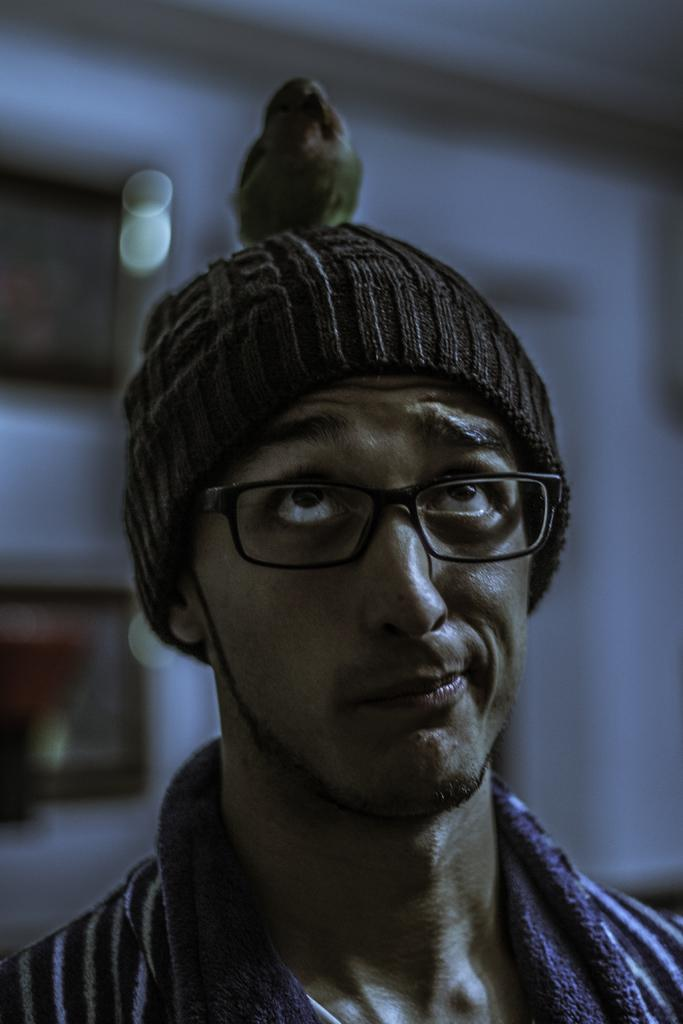What is the main subject of the picture? The main subject of the picture is a man. Can you describe what the man is wearing? The man is wearing a cap. Are there any animals present in the image? Yes, there is a bird on the man's head. What type of curtain can be seen in the background of the image? There is no curtain present in the image; it features a man with a bird on his head. Can you describe the swing that the man is using in the image? There is no swing present in the image; the man is standing still with a bird on his head. 